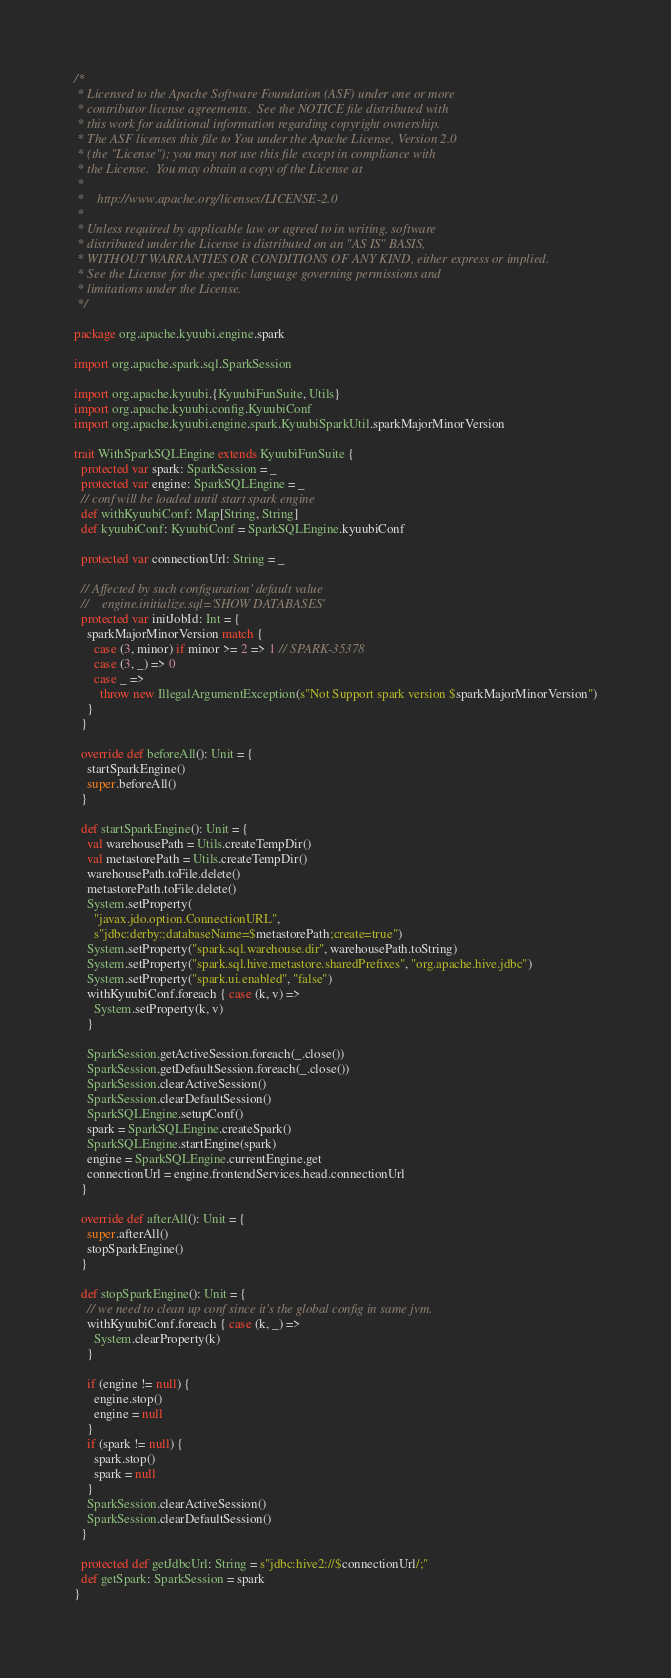Convert code to text. <code><loc_0><loc_0><loc_500><loc_500><_Scala_>/*
 * Licensed to the Apache Software Foundation (ASF) under one or more
 * contributor license agreements.  See the NOTICE file distributed with
 * this work for additional information regarding copyright ownership.
 * The ASF licenses this file to You under the Apache License, Version 2.0
 * (the "License"); you may not use this file except in compliance with
 * the License.  You may obtain a copy of the License at
 *
 *    http://www.apache.org/licenses/LICENSE-2.0
 *
 * Unless required by applicable law or agreed to in writing, software
 * distributed under the License is distributed on an "AS IS" BASIS,
 * WITHOUT WARRANTIES OR CONDITIONS OF ANY KIND, either express or implied.
 * See the License for the specific language governing permissions and
 * limitations under the License.
 */

package org.apache.kyuubi.engine.spark

import org.apache.spark.sql.SparkSession

import org.apache.kyuubi.{KyuubiFunSuite, Utils}
import org.apache.kyuubi.config.KyuubiConf
import org.apache.kyuubi.engine.spark.KyuubiSparkUtil.sparkMajorMinorVersion

trait WithSparkSQLEngine extends KyuubiFunSuite {
  protected var spark: SparkSession = _
  protected var engine: SparkSQLEngine = _
  // conf will be loaded until start spark engine
  def withKyuubiConf: Map[String, String]
  def kyuubiConf: KyuubiConf = SparkSQLEngine.kyuubiConf

  protected var connectionUrl: String = _

  // Affected by such configuration' default value
  //    engine.initialize.sql='SHOW DATABASES'
  protected var initJobId: Int = {
    sparkMajorMinorVersion match {
      case (3, minor) if minor >= 2 => 1 // SPARK-35378
      case (3, _) => 0
      case _ =>
        throw new IllegalArgumentException(s"Not Support spark version $sparkMajorMinorVersion")
    }
  }

  override def beforeAll(): Unit = {
    startSparkEngine()
    super.beforeAll()
  }

  def startSparkEngine(): Unit = {
    val warehousePath = Utils.createTempDir()
    val metastorePath = Utils.createTempDir()
    warehousePath.toFile.delete()
    metastorePath.toFile.delete()
    System.setProperty(
      "javax.jdo.option.ConnectionURL",
      s"jdbc:derby:;databaseName=$metastorePath;create=true")
    System.setProperty("spark.sql.warehouse.dir", warehousePath.toString)
    System.setProperty("spark.sql.hive.metastore.sharedPrefixes", "org.apache.hive.jdbc")
    System.setProperty("spark.ui.enabled", "false")
    withKyuubiConf.foreach { case (k, v) =>
      System.setProperty(k, v)
    }

    SparkSession.getActiveSession.foreach(_.close())
    SparkSession.getDefaultSession.foreach(_.close())
    SparkSession.clearActiveSession()
    SparkSession.clearDefaultSession()
    SparkSQLEngine.setupConf()
    spark = SparkSQLEngine.createSpark()
    SparkSQLEngine.startEngine(spark)
    engine = SparkSQLEngine.currentEngine.get
    connectionUrl = engine.frontendServices.head.connectionUrl
  }

  override def afterAll(): Unit = {
    super.afterAll()
    stopSparkEngine()
  }

  def stopSparkEngine(): Unit = {
    // we need to clean up conf since it's the global config in same jvm.
    withKyuubiConf.foreach { case (k, _) =>
      System.clearProperty(k)
    }

    if (engine != null) {
      engine.stop()
      engine = null
    }
    if (spark != null) {
      spark.stop()
      spark = null
    }
    SparkSession.clearActiveSession()
    SparkSession.clearDefaultSession()
  }

  protected def getJdbcUrl: String = s"jdbc:hive2://$connectionUrl/;"
  def getSpark: SparkSession = spark
}
</code> 